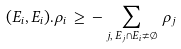Convert formula to latex. <formula><loc_0><loc_0><loc_500><loc_500>\, ( E _ { i } , E _ { i } ) . \rho _ { i } \, \geq \, - \sum _ { j , \, E _ { j } \cap E _ { i } \neq \emptyset } \, \rho _ { j }</formula> 